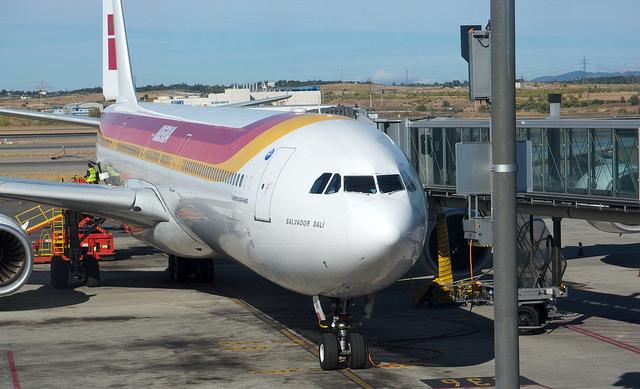What are the colors on the airplane fuselage?
Concise answer only. Pink and yellow. Is this plane moving?
Keep it brief. No. What kind of transportation would this be?
Answer briefly. Airplane. 